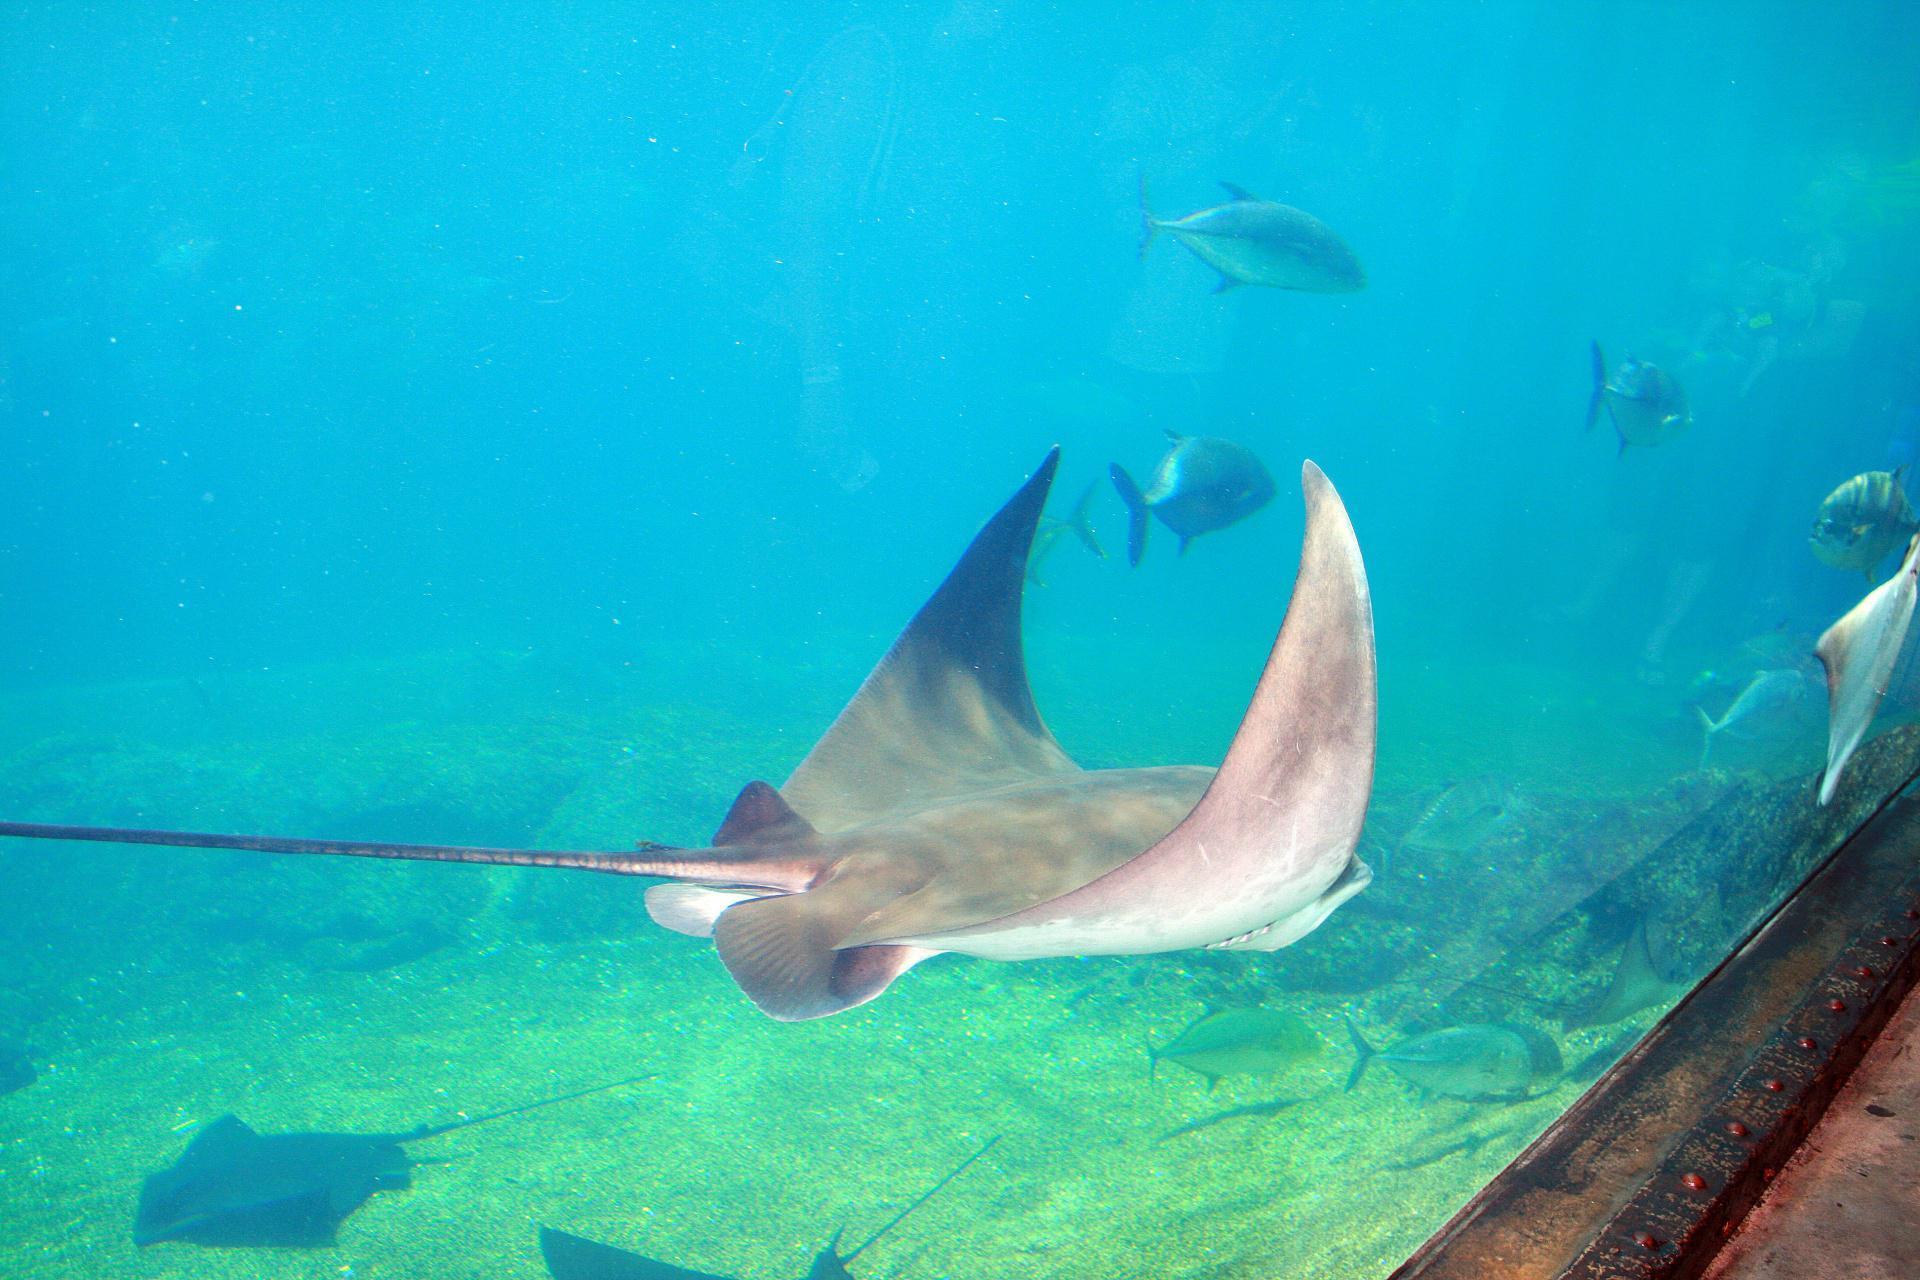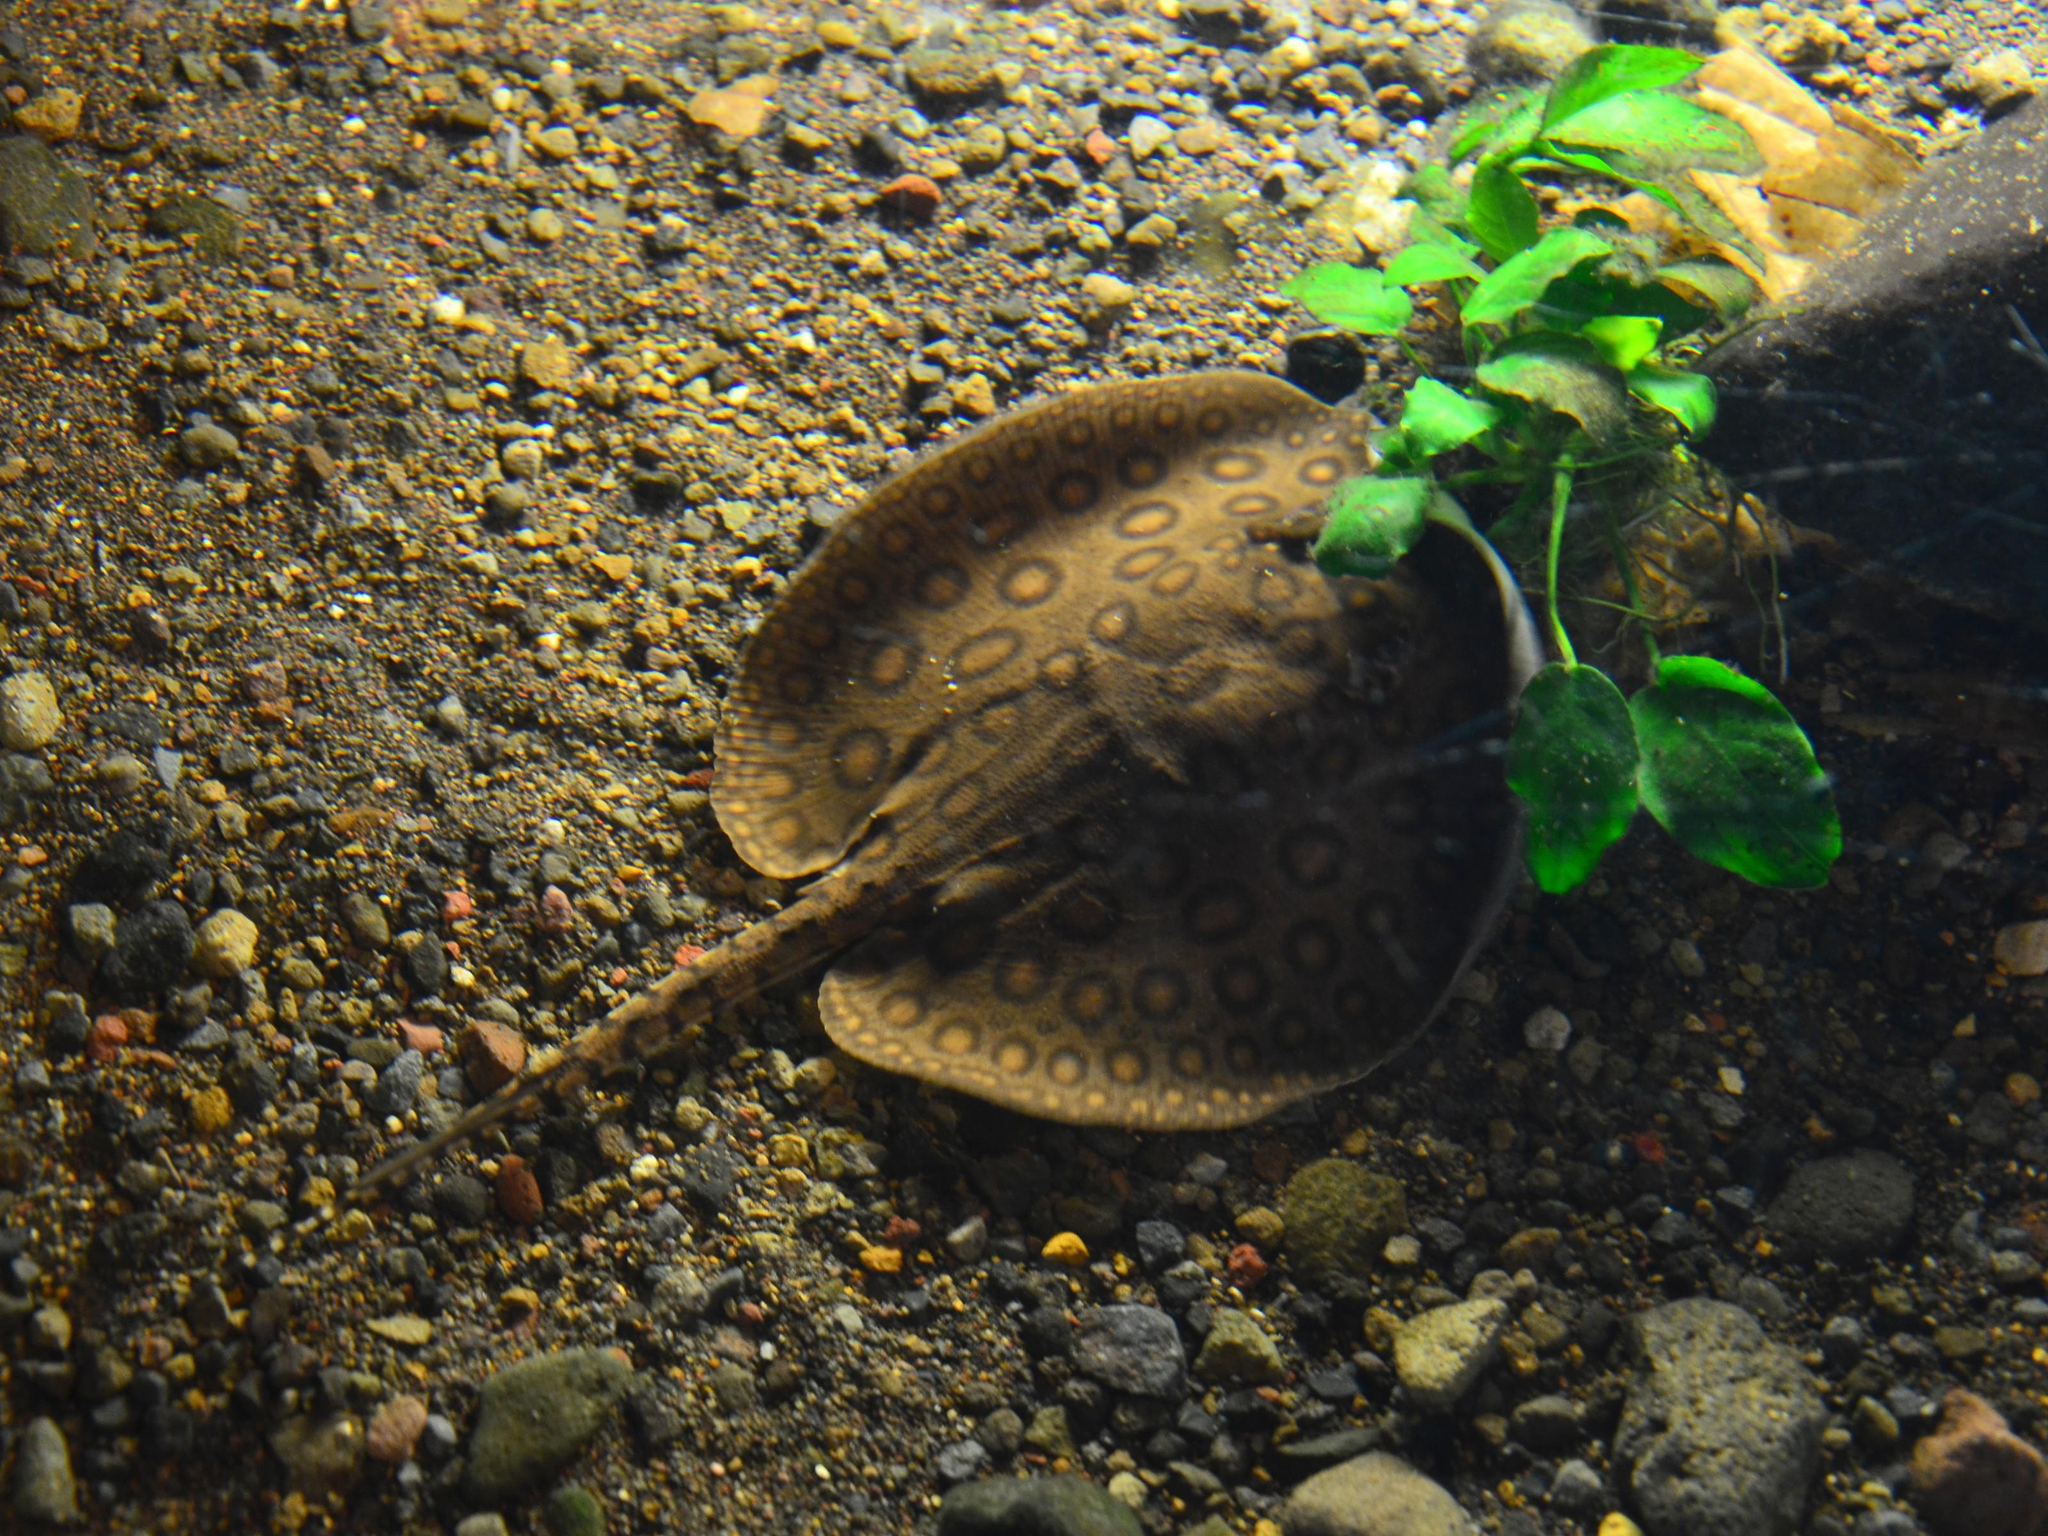The first image is the image on the left, the second image is the image on the right. For the images shown, is this caption "An image shows a round-shaped stingray with an all-over pattern of distinctive spots." true? Answer yes or no. Yes. 